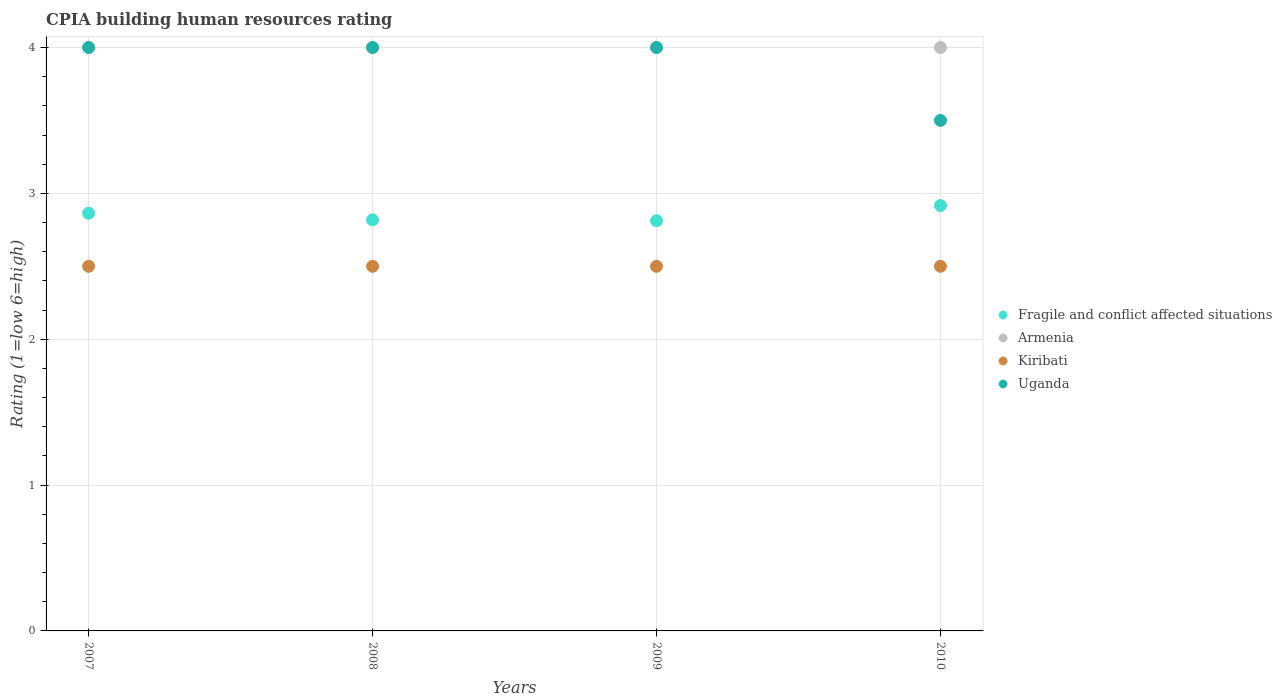What is the CPIA rating in Uganda in 2008?
Your response must be concise. 4. Across all years, what is the maximum CPIA rating in Fragile and conflict affected situations?
Provide a short and direct response. 2.92. In which year was the CPIA rating in Uganda maximum?
Provide a short and direct response. 2007. What is the difference between the CPIA rating in Armenia in 2007 and that in 2010?
Make the answer very short. 0. What is the average CPIA rating in Kiribati per year?
Keep it short and to the point. 2.5. In the year 2008, what is the difference between the CPIA rating in Armenia and CPIA rating in Uganda?
Your answer should be compact. 0. What is the ratio of the CPIA rating in Uganda in 2009 to that in 2010?
Provide a short and direct response. 1.14. Is the CPIA rating in Fragile and conflict affected situations in 2007 less than that in 2008?
Offer a very short reply. No. What is the difference between the highest and the lowest CPIA rating in Kiribati?
Offer a terse response. 0. In how many years, is the CPIA rating in Fragile and conflict affected situations greater than the average CPIA rating in Fragile and conflict affected situations taken over all years?
Provide a succinct answer. 2. Is it the case that in every year, the sum of the CPIA rating in Fragile and conflict affected situations and CPIA rating in Armenia  is greater than the sum of CPIA rating in Kiribati and CPIA rating in Uganda?
Offer a terse response. No. Is the CPIA rating in Kiribati strictly less than the CPIA rating in Uganda over the years?
Ensure brevity in your answer.  Yes. How many dotlines are there?
Make the answer very short. 4. How many years are there in the graph?
Your answer should be very brief. 4. What is the difference between two consecutive major ticks on the Y-axis?
Your response must be concise. 1. Are the values on the major ticks of Y-axis written in scientific E-notation?
Offer a very short reply. No. Does the graph contain any zero values?
Your response must be concise. No. Where does the legend appear in the graph?
Offer a terse response. Center right. How many legend labels are there?
Your answer should be compact. 4. What is the title of the graph?
Offer a terse response. CPIA building human resources rating. What is the label or title of the X-axis?
Make the answer very short. Years. What is the Rating (1=low 6=high) of Fragile and conflict affected situations in 2007?
Keep it short and to the point. 2.86. What is the Rating (1=low 6=high) of Fragile and conflict affected situations in 2008?
Provide a short and direct response. 2.82. What is the Rating (1=low 6=high) in Uganda in 2008?
Keep it short and to the point. 4. What is the Rating (1=low 6=high) of Fragile and conflict affected situations in 2009?
Ensure brevity in your answer.  2.81. What is the Rating (1=low 6=high) in Armenia in 2009?
Your answer should be very brief. 4. What is the Rating (1=low 6=high) of Kiribati in 2009?
Your answer should be very brief. 2.5. What is the Rating (1=low 6=high) in Uganda in 2009?
Make the answer very short. 4. What is the Rating (1=low 6=high) in Fragile and conflict affected situations in 2010?
Offer a terse response. 2.92. What is the Rating (1=low 6=high) of Armenia in 2010?
Your response must be concise. 4. Across all years, what is the maximum Rating (1=low 6=high) in Fragile and conflict affected situations?
Give a very brief answer. 2.92. Across all years, what is the maximum Rating (1=low 6=high) in Armenia?
Your answer should be very brief. 4. Across all years, what is the minimum Rating (1=low 6=high) in Fragile and conflict affected situations?
Your answer should be compact. 2.81. What is the total Rating (1=low 6=high) in Fragile and conflict affected situations in the graph?
Make the answer very short. 11.41. What is the difference between the Rating (1=low 6=high) of Fragile and conflict affected situations in 2007 and that in 2008?
Offer a terse response. 0.05. What is the difference between the Rating (1=low 6=high) of Armenia in 2007 and that in 2008?
Ensure brevity in your answer.  0. What is the difference between the Rating (1=low 6=high) of Kiribati in 2007 and that in 2008?
Your answer should be very brief. 0. What is the difference between the Rating (1=low 6=high) in Uganda in 2007 and that in 2008?
Give a very brief answer. 0. What is the difference between the Rating (1=low 6=high) of Fragile and conflict affected situations in 2007 and that in 2009?
Your answer should be very brief. 0.05. What is the difference between the Rating (1=low 6=high) in Armenia in 2007 and that in 2009?
Keep it short and to the point. 0. What is the difference between the Rating (1=low 6=high) of Fragile and conflict affected situations in 2007 and that in 2010?
Your answer should be very brief. -0.05. What is the difference between the Rating (1=low 6=high) of Uganda in 2007 and that in 2010?
Make the answer very short. 0.5. What is the difference between the Rating (1=low 6=high) of Fragile and conflict affected situations in 2008 and that in 2009?
Keep it short and to the point. 0.01. What is the difference between the Rating (1=low 6=high) of Kiribati in 2008 and that in 2009?
Offer a terse response. 0. What is the difference between the Rating (1=low 6=high) in Uganda in 2008 and that in 2009?
Your response must be concise. 0. What is the difference between the Rating (1=low 6=high) in Fragile and conflict affected situations in 2008 and that in 2010?
Provide a succinct answer. -0.1. What is the difference between the Rating (1=low 6=high) in Armenia in 2008 and that in 2010?
Your response must be concise. 0. What is the difference between the Rating (1=low 6=high) in Kiribati in 2008 and that in 2010?
Ensure brevity in your answer.  0. What is the difference between the Rating (1=low 6=high) in Uganda in 2008 and that in 2010?
Make the answer very short. 0.5. What is the difference between the Rating (1=low 6=high) of Fragile and conflict affected situations in 2009 and that in 2010?
Make the answer very short. -0.1. What is the difference between the Rating (1=low 6=high) in Armenia in 2009 and that in 2010?
Keep it short and to the point. 0. What is the difference between the Rating (1=low 6=high) in Uganda in 2009 and that in 2010?
Your answer should be compact. 0.5. What is the difference between the Rating (1=low 6=high) in Fragile and conflict affected situations in 2007 and the Rating (1=low 6=high) in Armenia in 2008?
Your answer should be compact. -1.14. What is the difference between the Rating (1=low 6=high) in Fragile and conflict affected situations in 2007 and the Rating (1=low 6=high) in Kiribati in 2008?
Offer a very short reply. 0.36. What is the difference between the Rating (1=low 6=high) in Fragile and conflict affected situations in 2007 and the Rating (1=low 6=high) in Uganda in 2008?
Ensure brevity in your answer.  -1.14. What is the difference between the Rating (1=low 6=high) in Armenia in 2007 and the Rating (1=low 6=high) in Kiribati in 2008?
Ensure brevity in your answer.  1.5. What is the difference between the Rating (1=low 6=high) in Kiribati in 2007 and the Rating (1=low 6=high) in Uganda in 2008?
Give a very brief answer. -1.5. What is the difference between the Rating (1=low 6=high) of Fragile and conflict affected situations in 2007 and the Rating (1=low 6=high) of Armenia in 2009?
Your answer should be compact. -1.14. What is the difference between the Rating (1=low 6=high) in Fragile and conflict affected situations in 2007 and the Rating (1=low 6=high) in Kiribati in 2009?
Provide a short and direct response. 0.36. What is the difference between the Rating (1=low 6=high) in Fragile and conflict affected situations in 2007 and the Rating (1=low 6=high) in Uganda in 2009?
Your answer should be very brief. -1.14. What is the difference between the Rating (1=low 6=high) in Fragile and conflict affected situations in 2007 and the Rating (1=low 6=high) in Armenia in 2010?
Ensure brevity in your answer.  -1.14. What is the difference between the Rating (1=low 6=high) in Fragile and conflict affected situations in 2007 and the Rating (1=low 6=high) in Kiribati in 2010?
Provide a short and direct response. 0.36. What is the difference between the Rating (1=low 6=high) of Fragile and conflict affected situations in 2007 and the Rating (1=low 6=high) of Uganda in 2010?
Ensure brevity in your answer.  -0.64. What is the difference between the Rating (1=low 6=high) in Armenia in 2007 and the Rating (1=low 6=high) in Uganda in 2010?
Make the answer very short. 0.5. What is the difference between the Rating (1=low 6=high) in Fragile and conflict affected situations in 2008 and the Rating (1=low 6=high) in Armenia in 2009?
Give a very brief answer. -1.18. What is the difference between the Rating (1=low 6=high) of Fragile and conflict affected situations in 2008 and the Rating (1=low 6=high) of Kiribati in 2009?
Keep it short and to the point. 0.32. What is the difference between the Rating (1=low 6=high) in Fragile and conflict affected situations in 2008 and the Rating (1=low 6=high) in Uganda in 2009?
Provide a succinct answer. -1.18. What is the difference between the Rating (1=low 6=high) of Armenia in 2008 and the Rating (1=low 6=high) of Kiribati in 2009?
Offer a terse response. 1.5. What is the difference between the Rating (1=low 6=high) of Armenia in 2008 and the Rating (1=low 6=high) of Uganda in 2009?
Provide a succinct answer. 0. What is the difference between the Rating (1=low 6=high) of Fragile and conflict affected situations in 2008 and the Rating (1=low 6=high) of Armenia in 2010?
Your response must be concise. -1.18. What is the difference between the Rating (1=low 6=high) in Fragile and conflict affected situations in 2008 and the Rating (1=low 6=high) in Kiribati in 2010?
Your response must be concise. 0.32. What is the difference between the Rating (1=low 6=high) in Fragile and conflict affected situations in 2008 and the Rating (1=low 6=high) in Uganda in 2010?
Your response must be concise. -0.68. What is the difference between the Rating (1=low 6=high) in Fragile and conflict affected situations in 2009 and the Rating (1=low 6=high) in Armenia in 2010?
Make the answer very short. -1.19. What is the difference between the Rating (1=low 6=high) in Fragile and conflict affected situations in 2009 and the Rating (1=low 6=high) in Kiribati in 2010?
Offer a very short reply. 0.31. What is the difference between the Rating (1=low 6=high) of Fragile and conflict affected situations in 2009 and the Rating (1=low 6=high) of Uganda in 2010?
Your response must be concise. -0.69. What is the difference between the Rating (1=low 6=high) in Armenia in 2009 and the Rating (1=low 6=high) in Kiribati in 2010?
Ensure brevity in your answer.  1.5. What is the difference between the Rating (1=low 6=high) in Armenia in 2009 and the Rating (1=low 6=high) in Uganda in 2010?
Keep it short and to the point. 0.5. What is the average Rating (1=low 6=high) in Fragile and conflict affected situations per year?
Your response must be concise. 2.85. What is the average Rating (1=low 6=high) in Uganda per year?
Offer a terse response. 3.88. In the year 2007, what is the difference between the Rating (1=low 6=high) in Fragile and conflict affected situations and Rating (1=low 6=high) in Armenia?
Make the answer very short. -1.14. In the year 2007, what is the difference between the Rating (1=low 6=high) of Fragile and conflict affected situations and Rating (1=low 6=high) of Kiribati?
Your answer should be very brief. 0.36. In the year 2007, what is the difference between the Rating (1=low 6=high) in Fragile and conflict affected situations and Rating (1=low 6=high) in Uganda?
Your response must be concise. -1.14. In the year 2007, what is the difference between the Rating (1=low 6=high) of Armenia and Rating (1=low 6=high) of Uganda?
Your response must be concise. 0. In the year 2008, what is the difference between the Rating (1=low 6=high) of Fragile and conflict affected situations and Rating (1=low 6=high) of Armenia?
Keep it short and to the point. -1.18. In the year 2008, what is the difference between the Rating (1=low 6=high) of Fragile and conflict affected situations and Rating (1=low 6=high) of Kiribati?
Offer a very short reply. 0.32. In the year 2008, what is the difference between the Rating (1=low 6=high) in Fragile and conflict affected situations and Rating (1=low 6=high) in Uganda?
Your response must be concise. -1.18. In the year 2008, what is the difference between the Rating (1=low 6=high) in Armenia and Rating (1=low 6=high) in Uganda?
Your response must be concise. 0. In the year 2008, what is the difference between the Rating (1=low 6=high) in Kiribati and Rating (1=low 6=high) in Uganda?
Keep it short and to the point. -1.5. In the year 2009, what is the difference between the Rating (1=low 6=high) of Fragile and conflict affected situations and Rating (1=low 6=high) of Armenia?
Your answer should be compact. -1.19. In the year 2009, what is the difference between the Rating (1=low 6=high) of Fragile and conflict affected situations and Rating (1=low 6=high) of Kiribati?
Provide a short and direct response. 0.31. In the year 2009, what is the difference between the Rating (1=low 6=high) in Fragile and conflict affected situations and Rating (1=low 6=high) in Uganda?
Your answer should be compact. -1.19. In the year 2009, what is the difference between the Rating (1=low 6=high) in Armenia and Rating (1=low 6=high) in Uganda?
Your answer should be compact. 0. In the year 2009, what is the difference between the Rating (1=low 6=high) of Kiribati and Rating (1=low 6=high) of Uganda?
Your answer should be compact. -1.5. In the year 2010, what is the difference between the Rating (1=low 6=high) in Fragile and conflict affected situations and Rating (1=low 6=high) in Armenia?
Provide a short and direct response. -1.08. In the year 2010, what is the difference between the Rating (1=low 6=high) in Fragile and conflict affected situations and Rating (1=low 6=high) in Kiribati?
Make the answer very short. 0.42. In the year 2010, what is the difference between the Rating (1=low 6=high) of Fragile and conflict affected situations and Rating (1=low 6=high) of Uganda?
Ensure brevity in your answer.  -0.58. What is the ratio of the Rating (1=low 6=high) of Fragile and conflict affected situations in 2007 to that in 2008?
Keep it short and to the point. 1.02. What is the ratio of the Rating (1=low 6=high) of Kiribati in 2007 to that in 2008?
Your answer should be very brief. 1. What is the ratio of the Rating (1=low 6=high) of Uganda in 2007 to that in 2008?
Your response must be concise. 1. What is the ratio of the Rating (1=low 6=high) in Fragile and conflict affected situations in 2007 to that in 2009?
Offer a terse response. 1.02. What is the ratio of the Rating (1=low 6=high) of Armenia in 2007 to that in 2009?
Provide a succinct answer. 1. What is the ratio of the Rating (1=low 6=high) in Fragile and conflict affected situations in 2007 to that in 2010?
Provide a short and direct response. 0.98. What is the ratio of the Rating (1=low 6=high) of Armenia in 2007 to that in 2010?
Your answer should be compact. 1. What is the ratio of the Rating (1=low 6=high) of Uganda in 2007 to that in 2010?
Ensure brevity in your answer.  1.14. What is the ratio of the Rating (1=low 6=high) of Armenia in 2008 to that in 2009?
Provide a succinct answer. 1. What is the ratio of the Rating (1=low 6=high) in Kiribati in 2008 to that in 2009?
Ensure brevity in your answer.  1. What is the ratio of the Rating (1=low 6=high) in Fragile and conflict affected situations in 2008 to that in 2010?
Your answer should be very brief. 0.97. What is the ratio of the Rating (1=low 6=high) in Armenia in 2008 to that in 2010?
Your answer should be very brief. 1. What is the ratio of the Rating (1=low 6=high) in Kiribati in 2008 to that in 2010?
Offer a very short reply. 1. What is the ratio of the Rating (1=low 6=high) in Uganda in 2009 to that in 2010?
Offer a very short reply. 1.14. What is the difference between the highest and the second highest Rating (1=low 6=high) of Fragile and conflict affected situations?
Keep it short and to the point. 0.05. What is the difference between the highest and the second highest Rating (1=low 6=high) of Armenia?
Offer a very short reply. 0. What is the difference between the highest and the lowest Rating (1=low 6=high) in Fragile and conflict affected situations?
Provide a short and direct response. 0.1. What is the difference between the highest and the lowest Rating (1=low 6=high) in Uganda?
Provide a succinct answer. 0.5. 